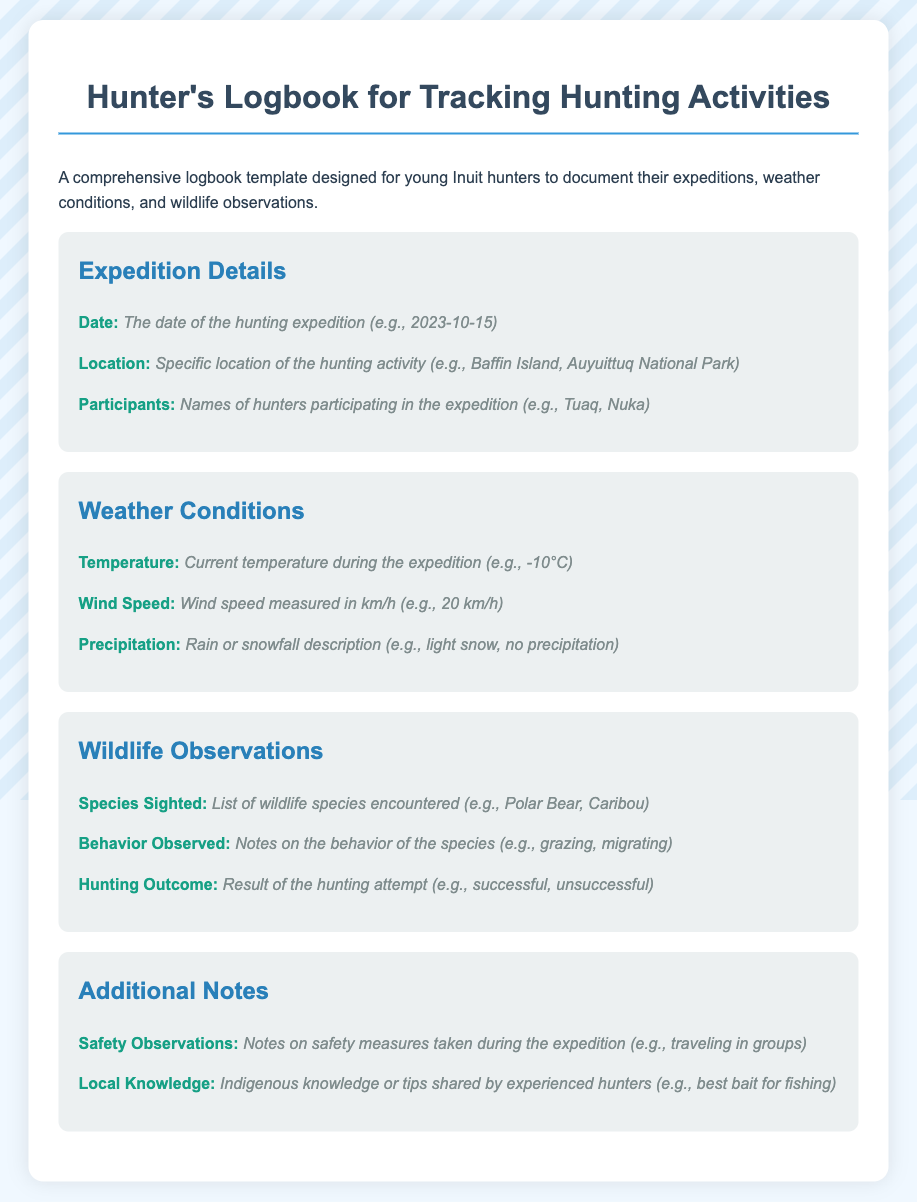what is the title of the logbook? The title of the logbook is provided in the document header.
Answer: Hunter's Logbook for Tracking Hunting Activities what date format is used in the expedition details? The document specifies a standard format for recording dates.
Answer: YYYY-MM-DD what is an example of a species sighted? The logbook template includes a section for wildlife observations, listing species that may be encountered.
Answer: Polar Bear how is temperature recorded in the logbook? Temperature is documented in degrees Celsius in the weather conditions section.
Answer: -10°C what is one of the safety observations suggested? The logbook provides space for safety notes during expeditions, implying necessary precautions.
Answer: traveling in groups how many sections are in the logbook template? The logbook contains multiple organized categories for inputting information effectively.
Answer: Four what behavior might be observed in wildlife? The template emphasizes noting various actions taken by the species during observations.
Answer: grazing who are examples of participants listed? Participants' names are to be recorded under the expedition details section, indicating collaboration on excursions.
Answer: Tuaq, Nuka what is the purpose of the logbook? The introduction of the logbook explains its intended use for hunters.
Answer: Document expeditions, weather conditions, and wildlife observations 